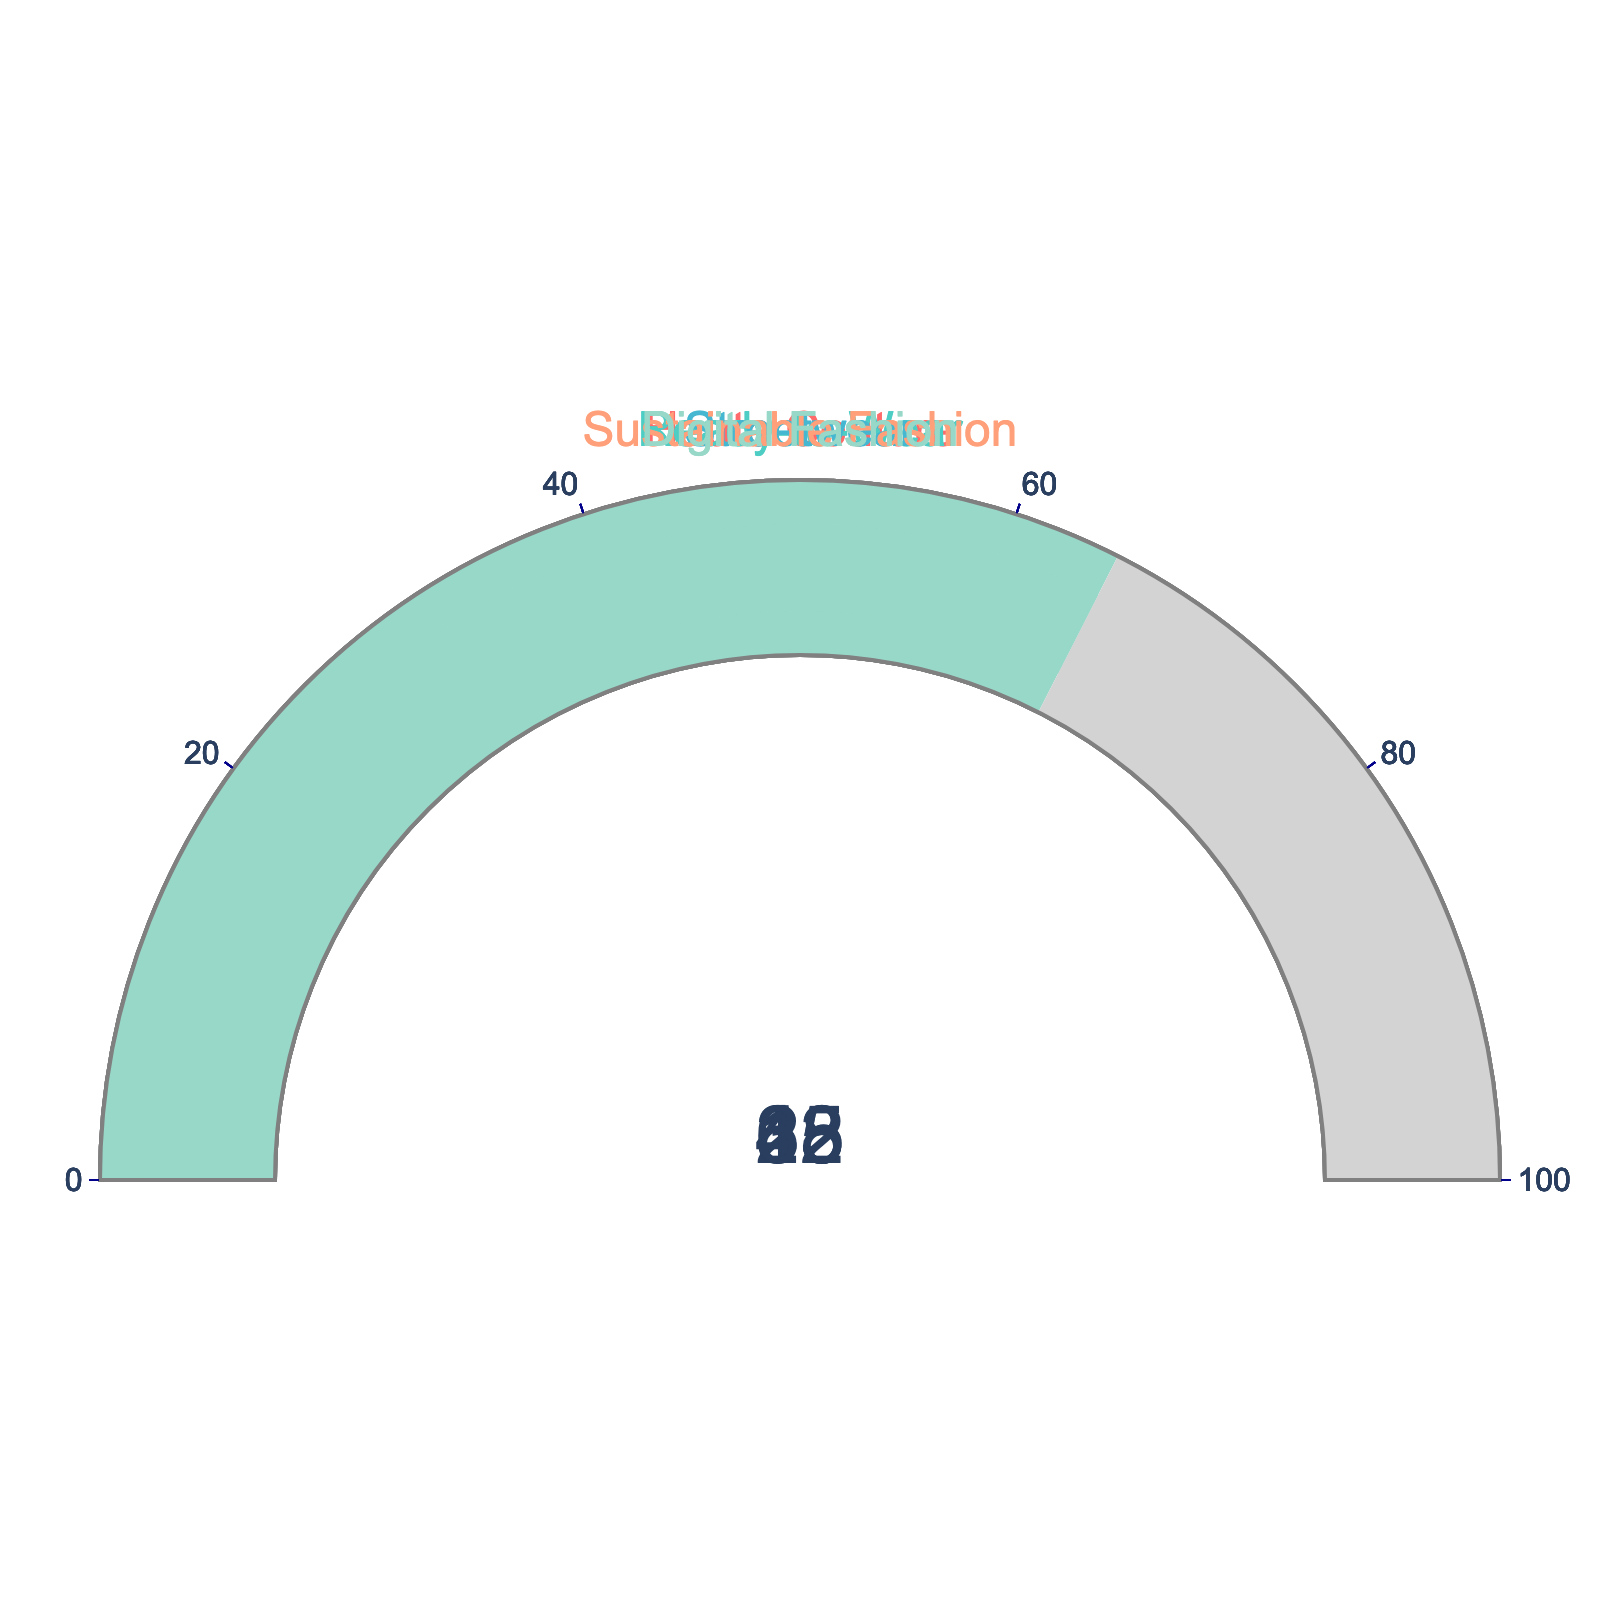what percentage of fashion designers in the Digital Fashion category are using AI-generated patterns? The gauge chart for the Digital Fashion category shows a value of 65%, which represents the percentage of fashion designers using AI-generated patterns in this category.
Answer: 65% Which category has the lowest percentage of fashion designers using AI-generated patterns? The Haute Couture category has the lowest percentage, as indicated by its gauge showing a value of 15%.
Answer: Haute Couture What's the total percentage of fashion designers using AI-generated patterns in both Ready-to-Wear and Sustainable Fashion categories? Adding the percentages for Ready-to-Wear (28) and Sustainable Fashion (33) gives 28 + 33 = 61%.
Answer: 61% How much higher is the percentage for Streetwear compared to Haute Couture? The gauge for Streetwear shows 42% and for Haute Couture shows 15%. The difference is 42 - 15 = 27%.
Answer: 27% Which categories have more than 30% of fashion designers using AI-generated patterns? Observing the gauge charts, the Ready-to-Wear, Streetwear, Sustainable Fashion, and Digital Fashion categories have percentages greater than 30% (28%, 42%, 33%, and 65%, respectively).
Answer: Ready-to-Wear, Streetwear, Sustainable Fashion, Digital Fashion Is the percentage of designers using AI-generated patterns in Sustainable Fashion higher or lower than in Ready-to-Wear? The gauge for Sustainable Fashion shows 33%, which is higher than the Ready-to-Wear gauge showing 28%.
Answer: Higher What is the average percentage of fashion designers using AI-generated patterns across all categories? Adding all the percentages: 15 + 28 + 42 + 33 + 65 = 183. Dividing by the number of categories (5) gives 183 / 5 = 36.6%.
Answer: 36.6% What is the range of percentages of fashion designers using AI-generated patterns across different categories? The highest percentage is 65% (Digital Fashion) and the lowest is 15% (Haute Couture). The range is 65 - 15 = 50%.
Answer: 50% 